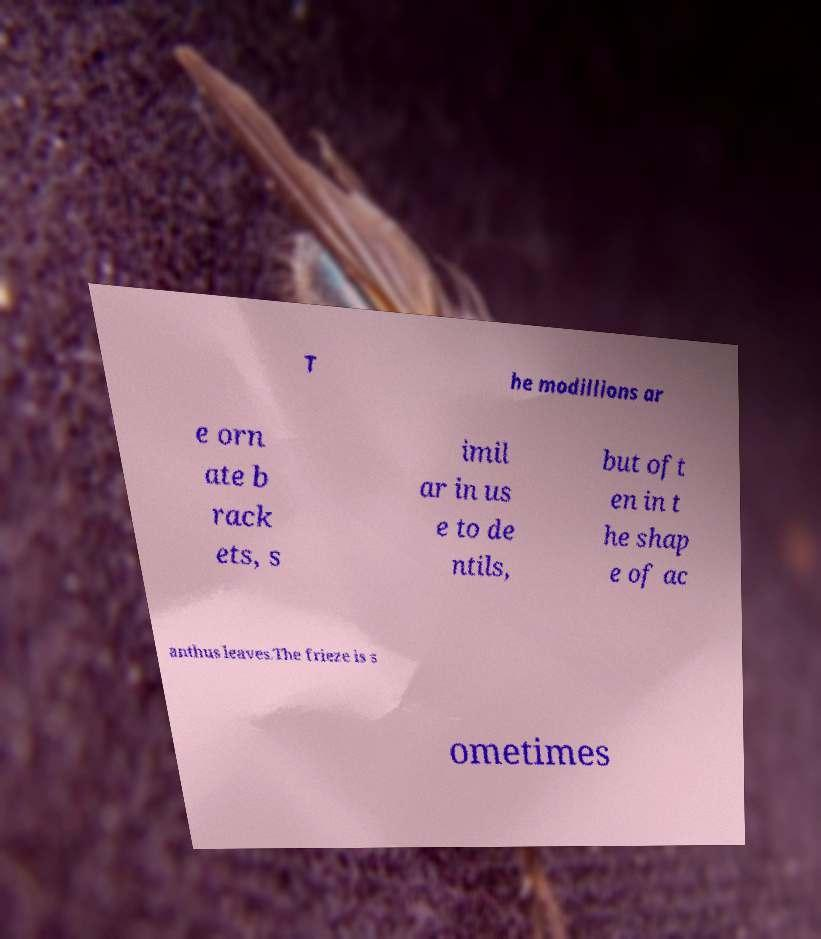Could you assist in decoding the text presented in this image and type it out clearly? T he modillions ar e orn ate b rack ets, s imil ar in us e to de ntils, but oft en in t he shap e of ac anthus leaves.The frieze is s ometimes 